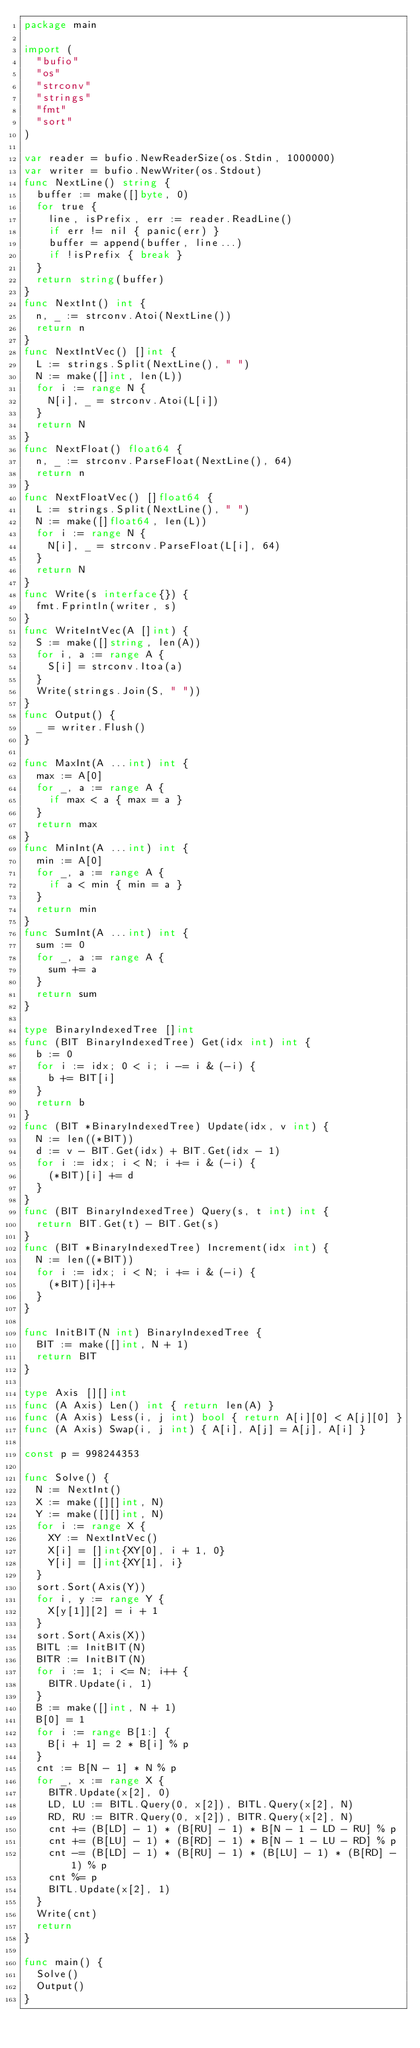Convert code to text. <code><loc_0><loc_0><loc_500><loc_500><_Go_>package main

import (
  "bufio"
  "os"
  "strconv"
  "strings"
  "fmt"
  "sort"
)

var reader = bufio.NewReaderSize(os.Stdin, 1000000)
var writer = bufio.NewWriter(os.Stdout)
func NextLine() string {
  buffer := make([]byte, 0)
  for true {
    line, isPrefix, err := reader.ReadLine()
    if err != nil { panic(err) }
    buffer = append(buffer, line...)
    if !isPrefix { break }
  }
  return string(buffer)
}
func NextInt() int {
  n, _ := strconv.Atoi(NextLine())
  return n
}
func NextIntVec() []int {
  L := strings.Split(NextLine(), " ")
  N := make([]int, len(L))
  for i := range N {
    N[i], _ = strconv.Atoi(L[i])
  }
  return N
}
func NextFloat() float64 {
  n, _ := strconv.ParseFloat(NextLine(), 64)
  return n
}
func NextFloatVec() []float64 {
  L := strings.Split(NextLine(), " ")
  N := make([]float64, len(L))
  for i := range N {
    N[i], _ = strconv.ParseFloat(L[i], 64)
  }
  return N
}
func Write(s interface{}) {
  fmt.Fprintln(writer, s)
}
func WriteIntVec(A []int) {
  S := make([]string, len(A))
  for i, a := range A {
    S[i] = strconv.Itoa(a)
  }
  Write(strings.Join(S, " "))
}
func Output() {
  _ = writer.Flush()
}

func MaxInt(A ...int) int {
  max := A[0]
  for _, a := range A {
    if max < a { max = a }
  }
  return max
}
func MinInt(A ...int) int {
  min := A[0]
  for _, a := range A {
    if a < min { min = a }
  }
  return min
}
func SumInt(A ...int) int {
  sum := 0
  for _, a := range A {
    sum += a
  }
  return sum
}

type BinaryIndexedTree []int
func (BIT BinaryIndexedTree) Get(idx int) int {
  b := 0
  for i := idx; 0 < i; i -= i & (-i) {
    b += BIT[i]
  }
  return b
}
func (BIT *BinaryIndexedTree) Update(idx, v int) {
  N := len((*BIT))
  d := v - BIT.Get(idx) + BIT.Get(idx - 1)
  for i := idx; i < N; i += i & (-i) {
    (*BIT)[i] += d
  }
}
func (BIT BinaryIndexedTree) Query(s, t int) int {
  return BIT.Get(t) - BIT.Get(s)
}
func (BIT *BinaryIndexedTree) Increment(idx int) {
  N := len((*BIT))
  for i := idx; i < N; i += i & (-i) {
    (*BIT)[i]++
  }
}

func InitBIT(N int) BinaryIndexedTree {
  BIT := make([]int, N + 1)
  return BIT
}

type Axis [][]int
func (A Axis) Len() int { return len(A) }
func (A Axis) Less(i, j int) bool { return A[i][0] < A[j][0] }
func (A Axis) Swap(i, j int) { A[i], A[j] = A[j], A[i] }

const p = 998244353

func Solve() {
  N := NextInt()
  X := make([][]int, N)
  Y := make([][]int, N)
  for i := range X {
    XY := NextIntVec()
    X[i] = []int{XY[0], i + 1, 0}
    Y[i] = []int{XY[1], i}
  }
  sort.Sort(Axis(Y))
  for i, y := range Y {
    X[y[1]][2] = i + 1
  }
  sort.Sort(Axis(X))
  BITL := InitBIT(N)
  BITR := InitBIT(N)
  for i := 1; i <= N; i++ {
    BITR.Update(i, 1)
  }
  B := make([]int, N + 1)
  B[0] = 1
  for i := range B[1:] {
    B[i + 1] = 2 * B[i] % p
  }
  cnt := B[N - 1] * N % p
  for _, x := range X {
    BITR.Update(x[2], 0)
    LD, LU := BITL.Query(0, x[2]), BITL.Query(x[2], N)
    RD, RU := BITR.Query(0, x[2]), BITR.Query(x[2], N)
    cnt += (B[LD] - 1) * (B[RU] - 1) * B[N - 1 - LD - RU] % p
    cnt += (B[LU] - 1) * (B[RD] - 1) * B[N - 1 - LU - RD] % p
    cnt -= (B[LD] - 1) * (B[RU] - 1) * (B[LU] - 1) * (B[RD] - 1) % p
    cnt %= p
    BITL.Update(x[2], 1)
  }
  Write(cnt)
  return
}

func main() {
  Solve()
  Output()
}</code> 